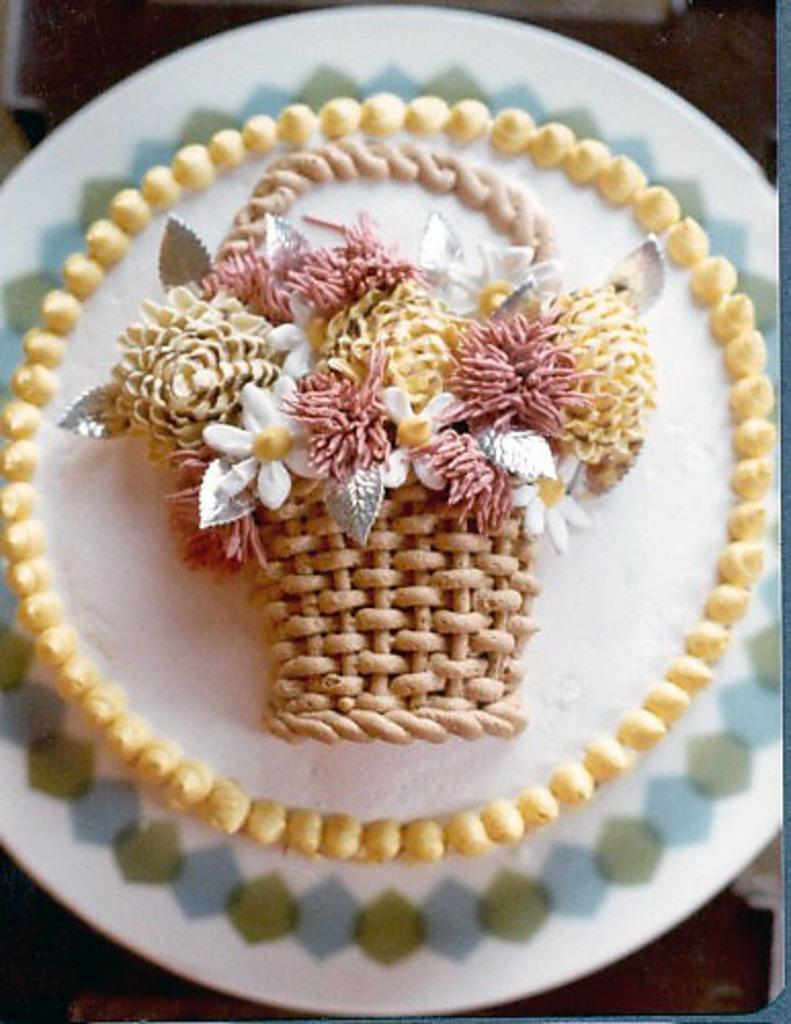What is the main object in the center of the image? There is a plate in the center of the image. What is on the plate? There is a cake on the plate. Can you describe the background of the image? The background of the image is blurred. What type of bread is being served to the queen in the image? There is no queen or bread present in the image; it features a plate with a cake and a blurred background. 